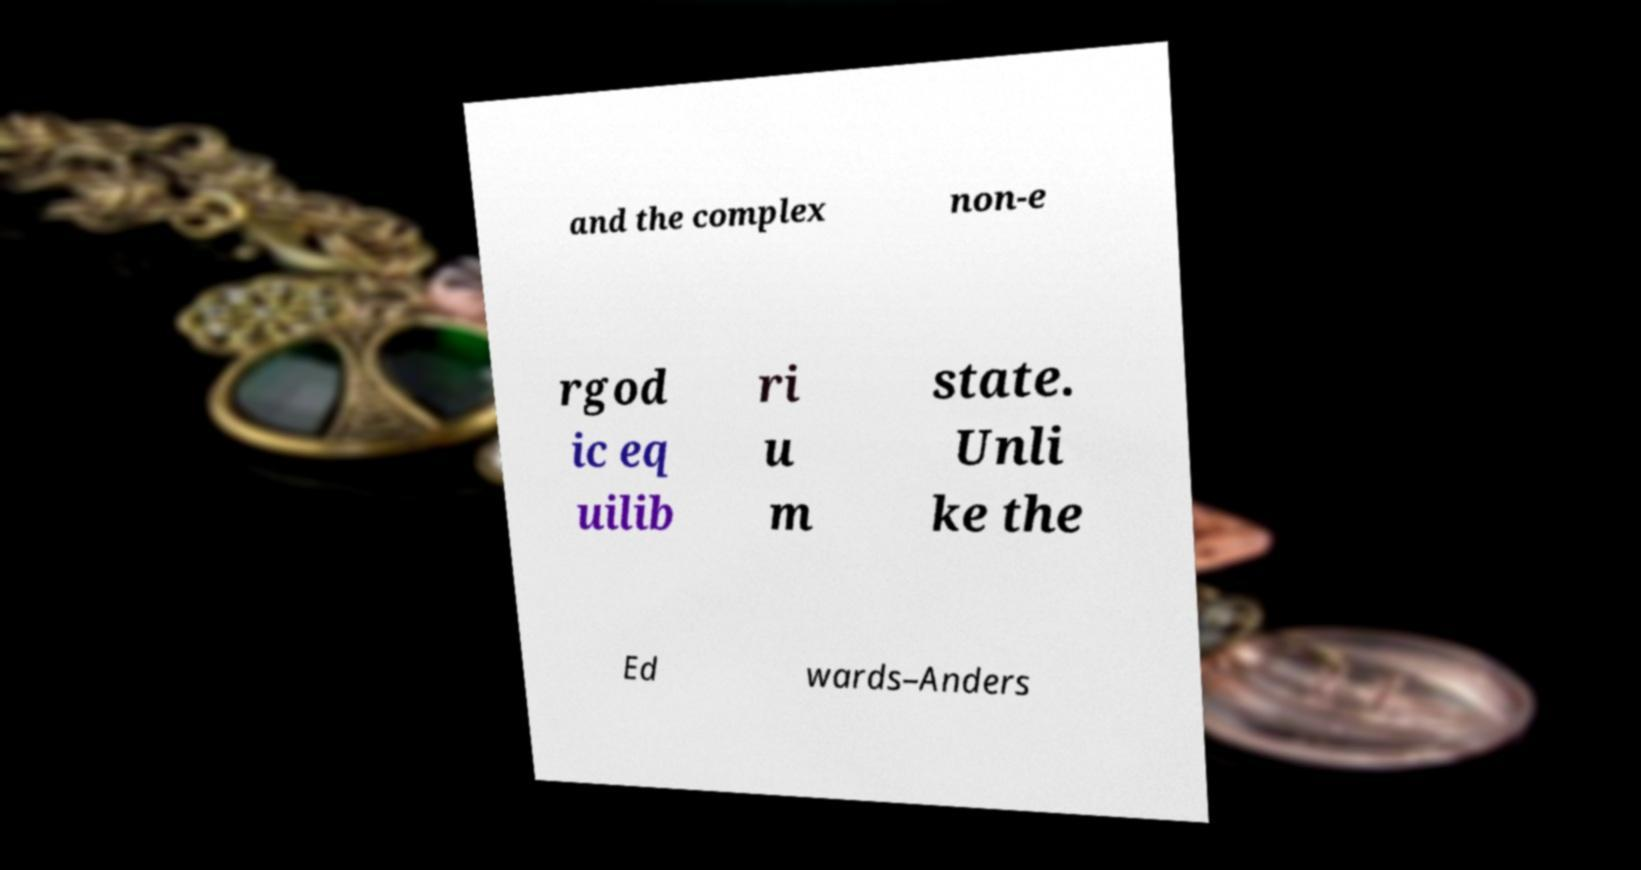Can you read and provide the text displayed in the image?This photo seems to have some interesting text. Can you extract and type it out for me? and the complex non-e rgod ic eq uilib ri u m state. Unli ke the Ed wards–Anders 